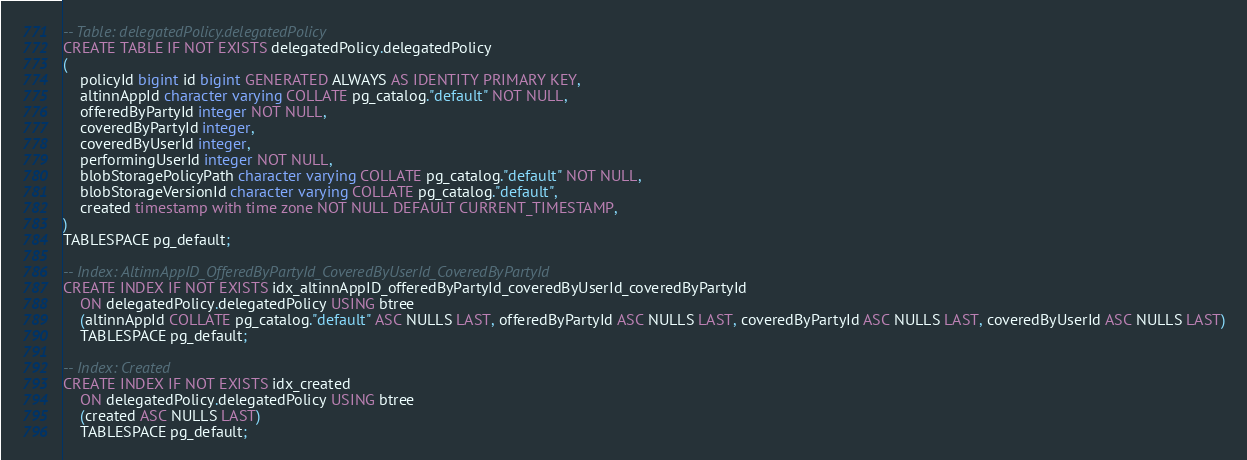Convert code to text. <code><loc_0><loc_0><loc_500><loc_500><_SQL_>-- Table: delegatedPolicy.delegatedPolicy
CREATE TABLE IF NOT EXISTS delegatedPolicy.delegatedPolicy
(
    policyId bigint id bigint GENERATED ALWAYS AS IDENTITY PRIMARY KEY,
    altinnAppId character varying COLLATE pg_catalog."default" NOT NULL,
    offeredByPartyId integer NOT NULL,
    coveredByPartyId integer,
    coveredByUserId integer,
    performingUserId integer NOT NULL,
    blobStoragePolicyPath character varying COLLATE pg_catalog."default" NOT NULL,
    blobStorageVersionId character varying COLLATE pg_catalog."default",
    created timestamp with time zone NOT NULL DEFAULT CURRENT_TIMESTAMP,
)
TABLESPACE pg_default;

-- Index: AltinnAppID_OfferedByPartyId_CoveredByUserId_CoveredByPartyId
CREATE INDEX IF NOT EXISTS idx_altinnAppID_offeredByPartyId_coveredByUserId_coveredByPartyId
    ON delegatedPolicy.delegatedPolicy USING btree
    (altinnAppId COLLATE pg_catalog."default" ASC NULLS LAST, offeredByPartyId ASC NULLS LAST, coveredByPartyId ASC NULLS LAST, coveredByUserId ASC NULLS LAST)
    TABLESPACE pg_default;

-- Index: Created
CREATE INDEX IF NOT EXISTS idx_created
    ON delegatedPolicy.delegatedPolicy USING btree
    (created ASC NULLS LAST)
    TABLESPACE pg_default;
</code> 